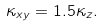<formula> <loc_0><loc_0><loc_500><loc_500>\kappa _ { x y } = 1 . 5 \kappa _ { z } .</formula> 